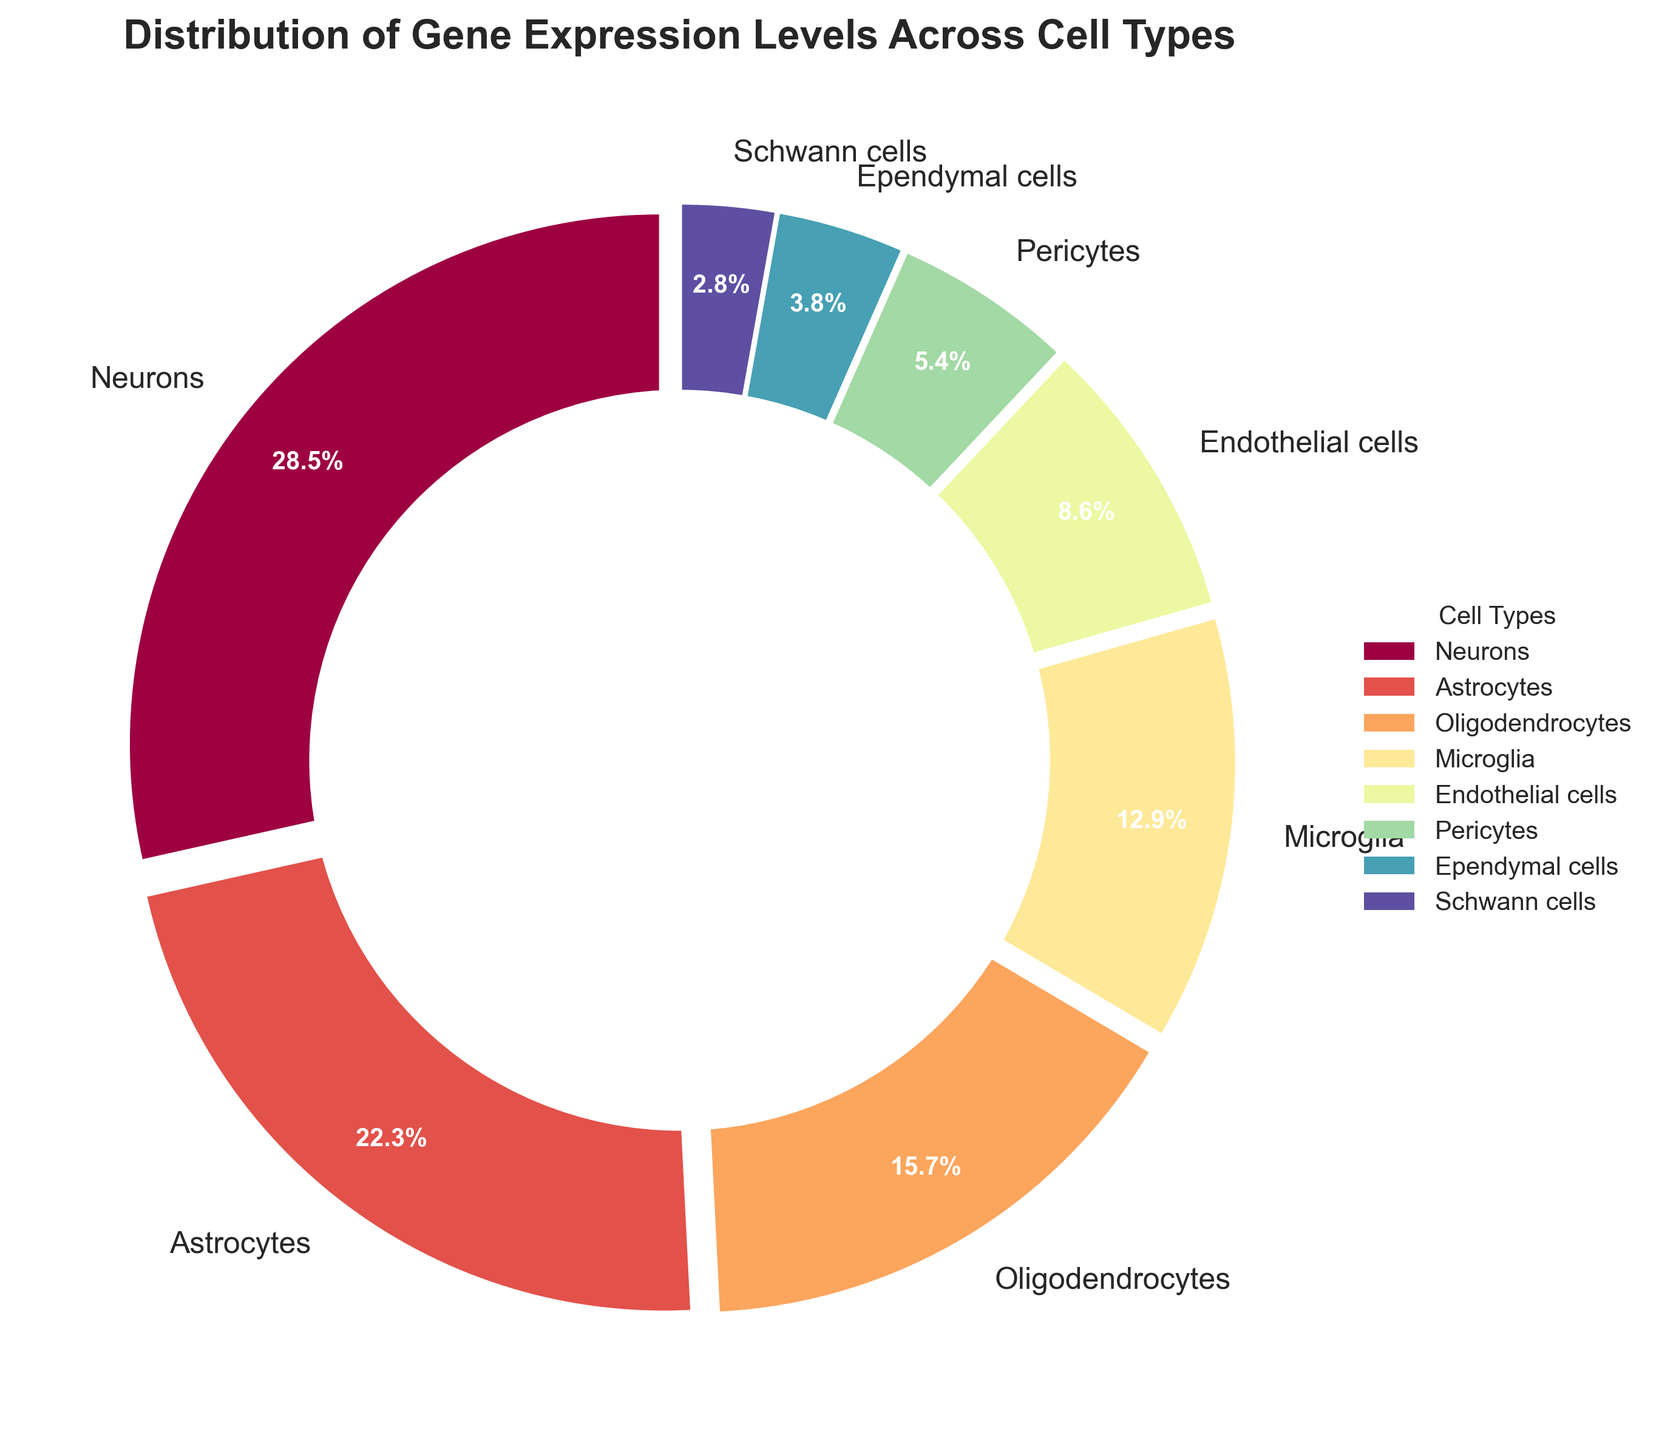What cell type has the highest gene expression percentage? By reading the plot, the largest segment corresponds to the cell type with the highest expression percentage. The "Neurons" segment is the largest.
Answer: Neurons Which cell type has the lowest gene expression percentage? By observing the smallest segment in the pie chart, we can identify the cell type with the lowest expression. The smallest segment corresponds to "Schwann cells."
Answer: Schwann cells What is the combined gene expression percentage of Microglia and Pericytes? Adding the percentages of Microglia (12.9%) and Pericytes (5.4%) gives the combined percentage. 12.9 + 5.4 = 18.3.
Answer: 18.3% Are Astrocytes expressed more or less than Endothelial cells? Comparing the pie chart segments, "Astrocytes" have a larger percentage than "Endothelial cells." Astrocytes have 22.3% vs. Endothelial cells at 8.6%.
Answer: More What is the sum of the expression percentages of the four least expressed cell types? Adding the percentages of the four least expressed cell types: Schwann cells (2.8%), Ependymal cells (3.8%), Pericytes (5.4%), and Endothelial cells (8.6%) gives the sum. 2.8 + 3.8 + 5.4 + 8.6 = 20.6.
Answer: 20.6% Which cell type is represented by a segment in the color red (approximation based on spectral coloring)? Based on the color scheme provided, "Neurons" typically appear in the red segment as it's the largest and starts the color gradient.
Answer: Neurons Are Oligodendrocytes or Microglia expressed more? What's the difference in their expression percentages? “Oligodendrocytes” have a percentage of 15.7%, whereas “Microglia” have a percentage of 12.9%. The difference is 15.7 - 12.9 = 2.8.
Answer: Oligodendrocytes, 2.8% What cell types collectively constitute more than 50% of the gene expression? By summing the percentages of the cell types from the largest until the sum exceeds 50%: Neurons (28.5%) + Astrocytes (22.3%) = 50.8%. So, Neurons and Astrocytes collectively exceed 50%.
Answer: Neurons and Astrocytes What is the average gene expression percentage of Neurons, Astrocytes, and Oligodendrocytes? To find the average, add the percentages of Neurons (28.5%), Astrocytes (22.3%), and Oligodendrocytes (15.7%) and divide by 3. (28.5 + 22.3 + 15.7) / 3 = 66.5 / 3 = 22.17.
Answer: 22.17% Which three cell types have the closest gene expression percentages and what are their values? Observing the pie chart, Microglia (12.9%), Endothelial cells (8.6%), and Pericytes (5.4%) have relatively proximal expression values.
Answer: Microglia (12.9%), Endothelial cells (8.6%), and Pericytes (5.4%) 